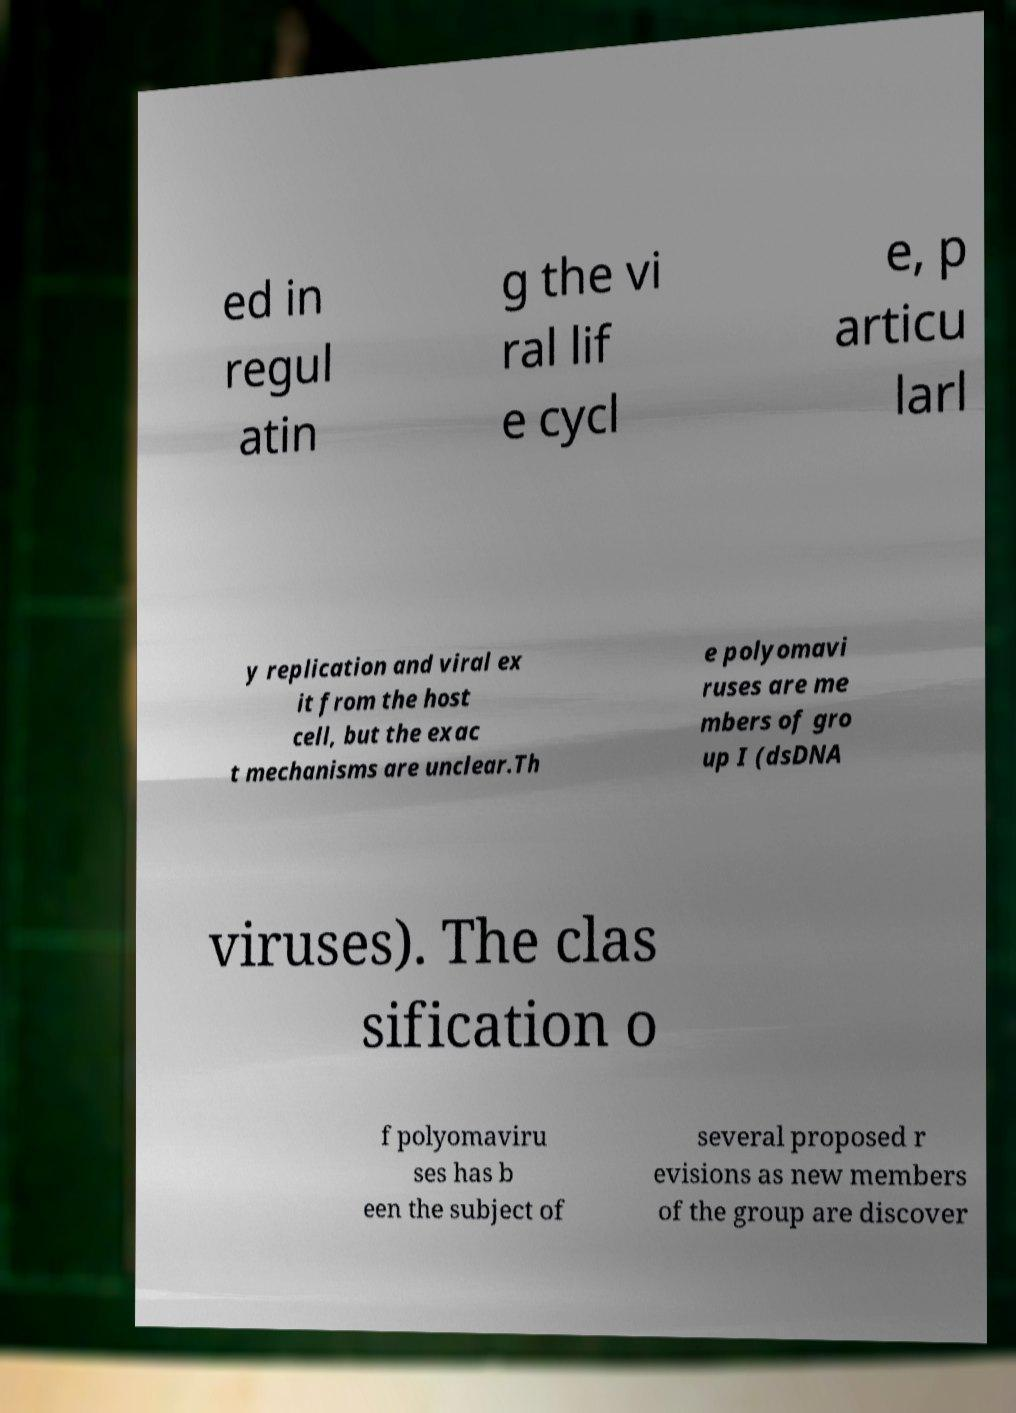Please read and relay the text visible in this image. What does it say? ed in regul atin g the vi ral lif e cycl e, p articu larl y replication and viral ex it from the host cell, but the exac t mechanisms are unclear.Th e polyomavi ruses are me mbers of gro up I (dsDNA viruses). The clas sification o f polyomaviru ses has b een the subject of several proposed r evisions as new members of the group are discover 